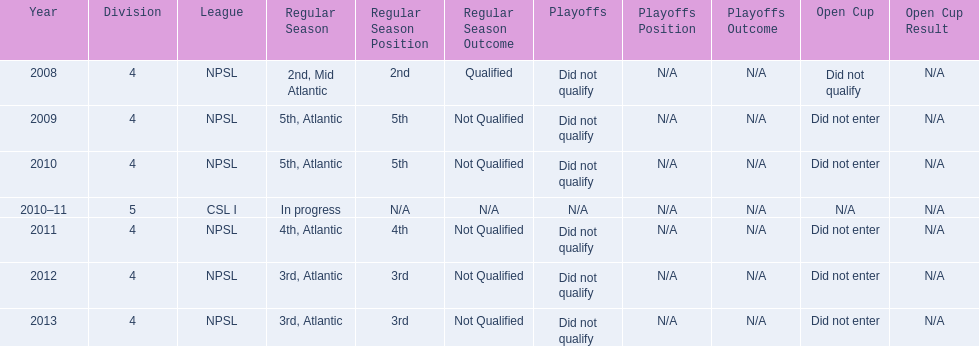What are the leagues? NPSL, NPSL, NPSL, CSL I, NPSL, NPSL, NPSL. Of these, what league is not npsl? CSL I. 